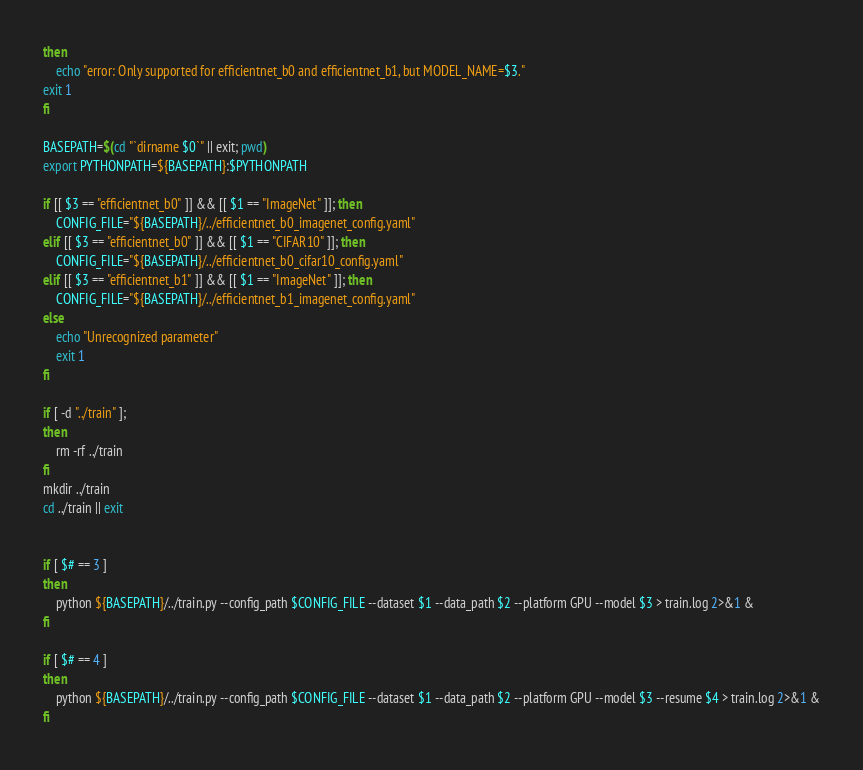<code> <loc_0><loc_0><loc_500><loc_500><_Bash_>then
    echo "error: Only supported for efficientnet_b0 and efficientnet_b1, but MODEL_NAME=$3."
exit 1
fi

BASEPATH=$(cd "`dirname $0`" || exit; pwd)
export PYTHONPATH=${BASEPATH}:$PYTHONPATH

if [[ $3 == "efficientnet_b0" ]] && [[ $1 == "ImageNet" ]]; then
    CONFIG_FILE="${BASEPATH}/../efficientnet_b0_imagenet_config.yaml"
elif [[ $3 == "efficientnet_b0" ]] && [[ $1 == "CIFAR10" ]]; then
    CONFIG_FILE="${BASEPATH}/../efficientnet_b0_cifar10_config.yaml"
elif [[ $3 == "efficientnet_b1" ]] && [[ $1 == "ImageNet" ]]; then
    CONFIG_FILE="${BASEPATH}/../efficientnet_b1_imagenet_config.yaml"
else
    echo "Unrecognized parameter"
    exit 1
fi

if [ -d "../train" ];
then
    rm -rf ../train
fi
mkdir ../train
cd ../train || exit


if [ $# == 3 ]
then
    python ${BASEPATH}/../train.py --config_path $CONFIG_FILE --dataset $1 --data_path $2 --platform GPU --model $3 > train.log 2>&1 &
fi

if [ $# == 4 ]
then
    python ${BASEPATH}/../train.py --config_path $CONFIG_FILE --dataset $1 --data_path $2 --platform GPU --model $3 --resume $4 > train.log 2>&1 &
fi
</code> 